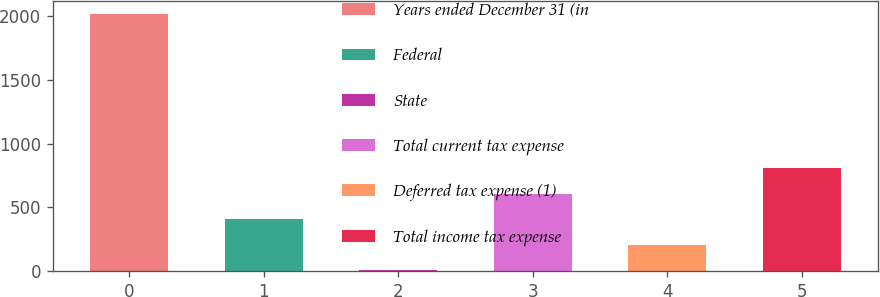<chart> <loc_0><loc_0><loc_500><loc_500><bar_chart><fcel>Years ended December 31 (in<fcel>Federal<fcel>State<fcel>Total current tax expense<fcel>Deferred tax expense (1)<fcel>Total income tax expense<nl><fcel>2012<fcel>408.08<fcel>7.1<fcel>608.57<fcel>207.59<fcel>809.06<nl></chart> 